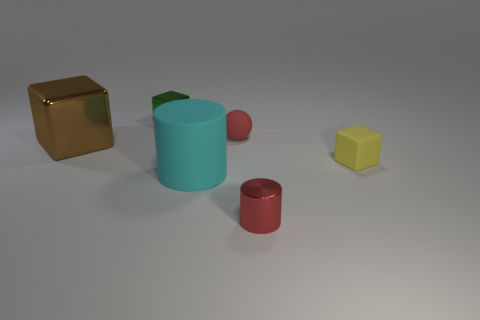Add 2 green cubes. How many objects exist? 8 Subtract all green blocks. How many blocks are left? 2 Subtract 2 cubes. How many cubes are left? 1 Subtract all brown blocks. How many blocks are left? 2 Add 3 big metallic blocks. How many big metallic blocks exist? 4 Subtract 1 cyan cylinders. How many objects are left? 5 Subtract all cylinders. How many objects are left? 4 Subtract all brown spheres. Subtract all brown cylinders. How many spheres are left? 1 Subtract all purple cylinders. How many cyan cubes are left? 0 Subtract all tiny red matte balls. Subtract all rubber objects. How many objects are left? 2 